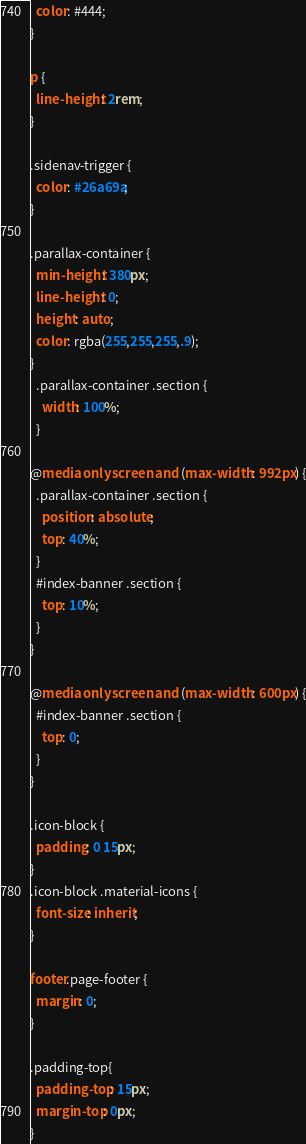<code> <loc_0><loc_0><loc_500><loc_500><_CSS_>  color: #444;
}

p {
  line-height: 2rem;
}

.sidenav-trigger {
  color: #26a69a;
}

.parallax-container {
  min-height: 380px;
  line-height: 0;
  height: auto;
  color: rgba(255,255,255,.9);
}
  .parallax-container .section {
    width: 100%;
  }

@media only screen and (max-width : 992px) {
  .parallax-container .section {
    position: absolute;
    top: 40%;
  }
  #index-banner .section {
    top: 10%;
  }
}

@media only screen and (max-width : 600px) {
  #index-banner .section {
    top: 0;
  }
}

.icon-block {
  padding: 0 15px;
}
.icon-block .material-icons {
  font-size: inherit;
}

footer.page-footer {
  margin: 0;
}

.padding-top{
  padding-top: 15px;
  margin-top: 0px;
}</code> 